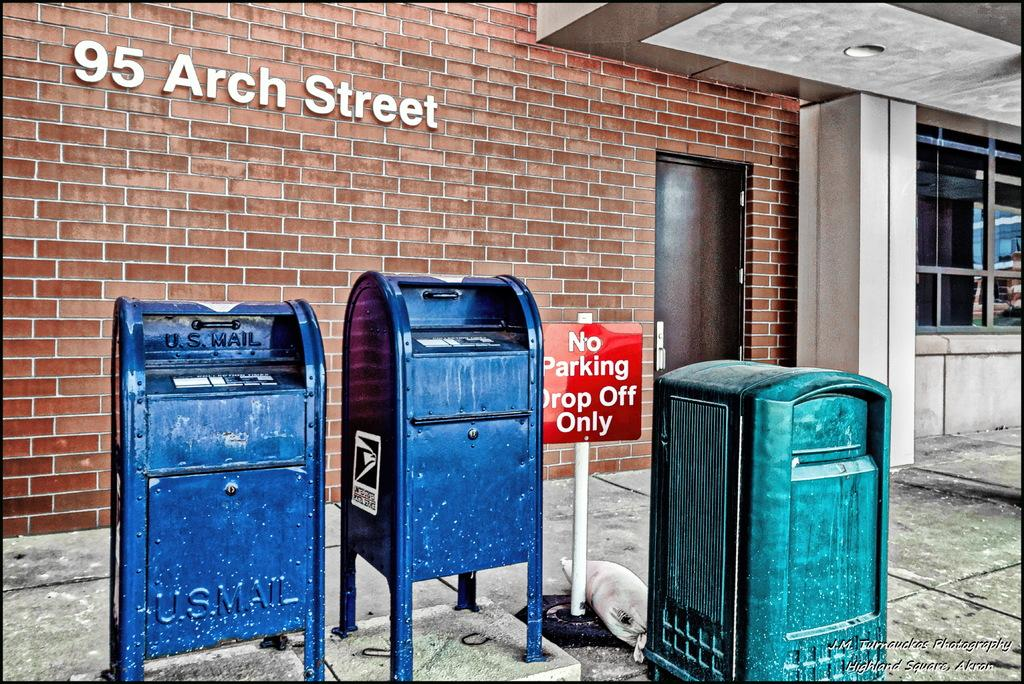<image>
Render a clear and concise summary of the photo. A no parking sign is standing next to a mail box. 